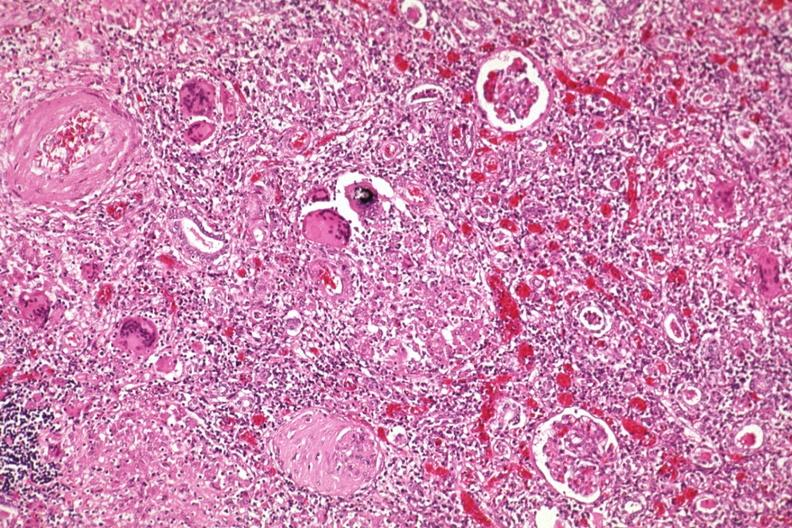s sarcoidosis present?
Answer the question using a single word or phrase. Yes 